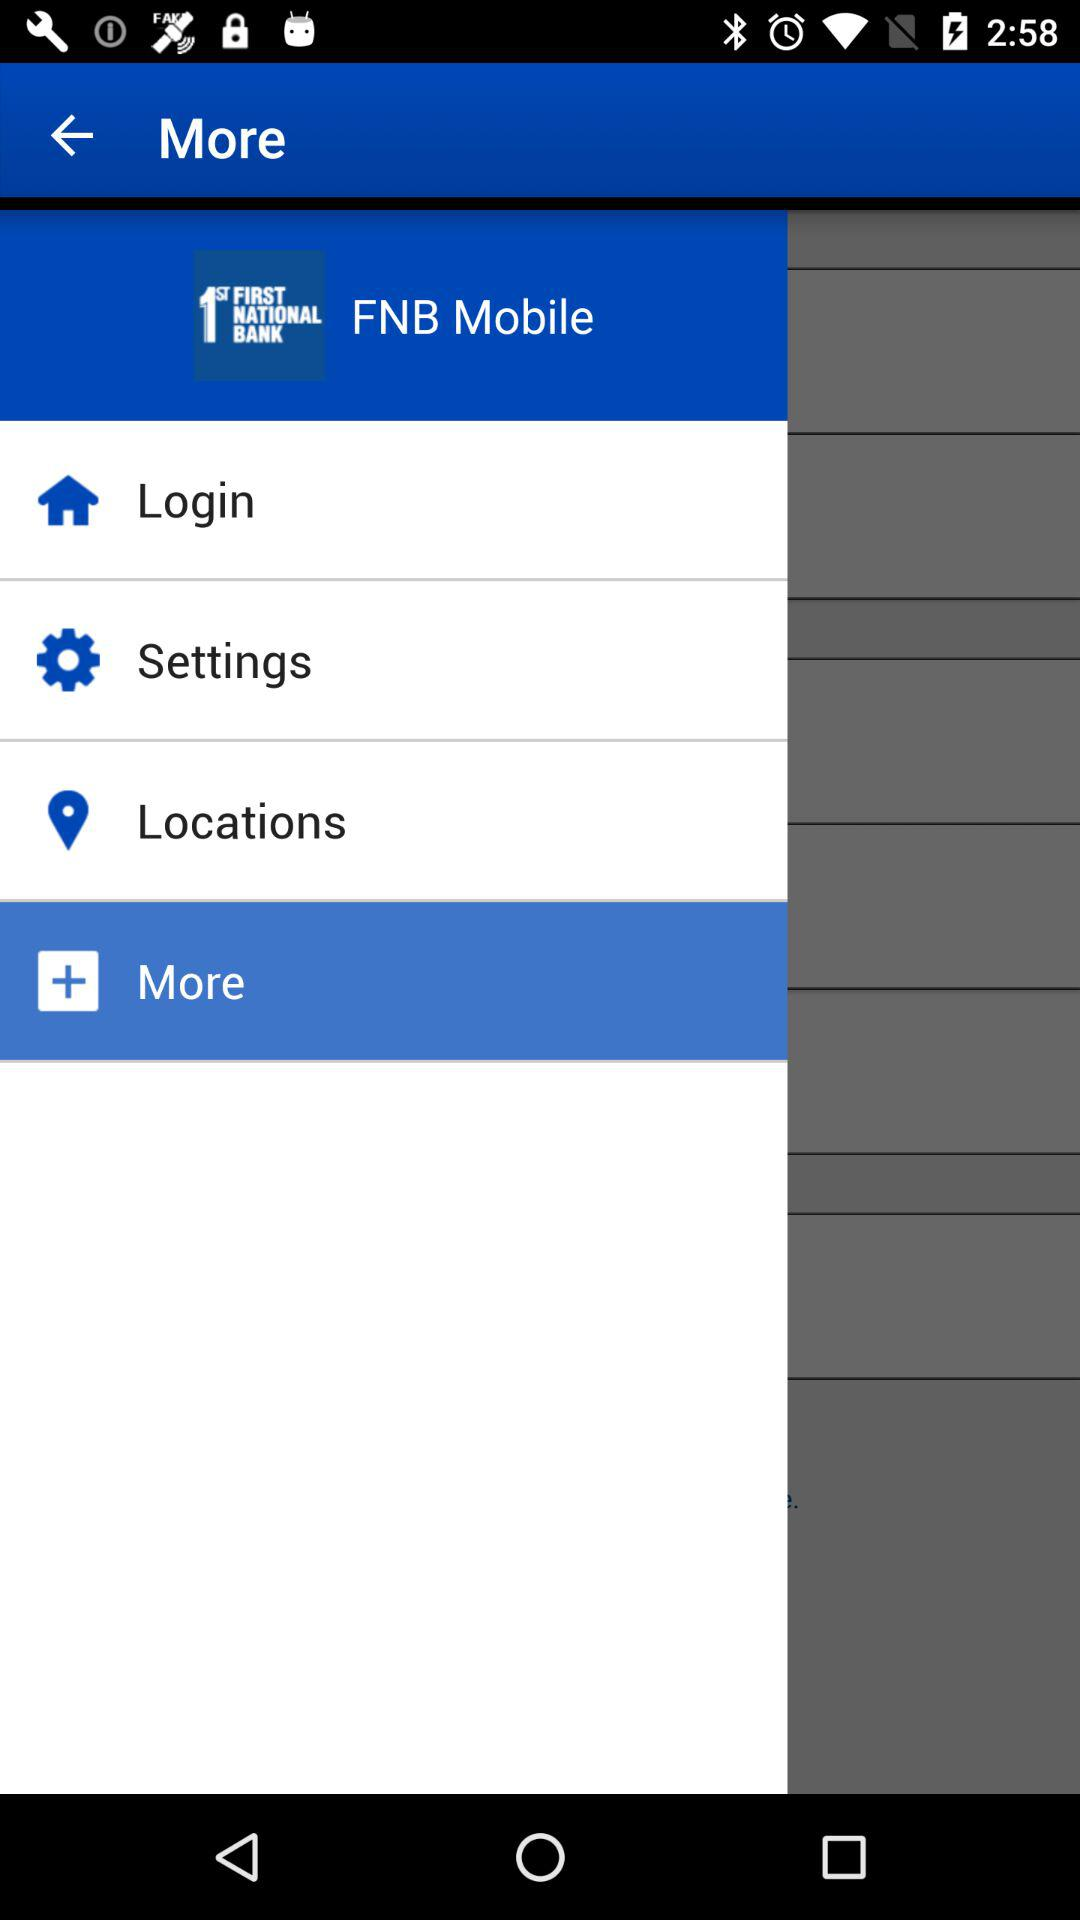What is the name of the application? The name of the application is "FNB Mobile". 